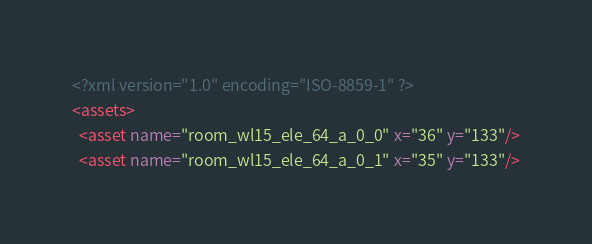<code> <loc_0><loc_0><loc_500><loc_500><_XML_><?xml version="1.0" encoding="ISO-8859-1" ?><assets>
  <asset name="room_wl15_ele_64_a_0_0" x="36" y="133"/>
  <asset name="room_wl15_ele_64_a_0_1" x="35" y="133"/></code> 